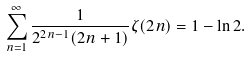<formula> <loc_0><loc_0><loc_500><loc_500>\sum _ { n = 1 } ^ { \infty } { \frac { 1 } { 2 ^ { 2 n - 1 } ( 2 n + 1 ) } } \zeta ( 2 n ) = 1 - \ln 2 .</formula> 